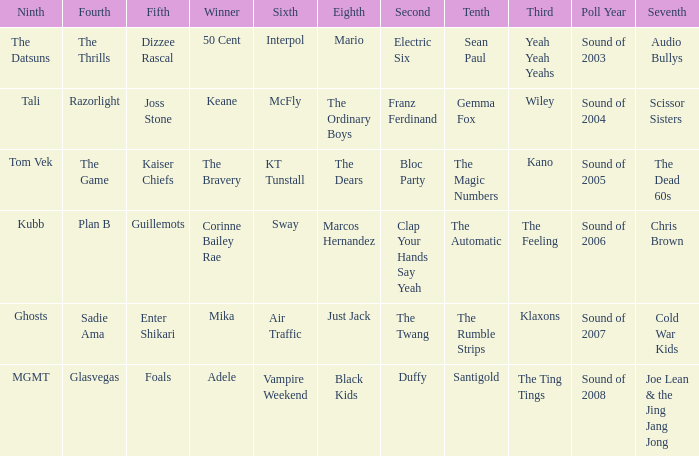When the 8th is Marcos Hernandez who was the 6th? Sway. 